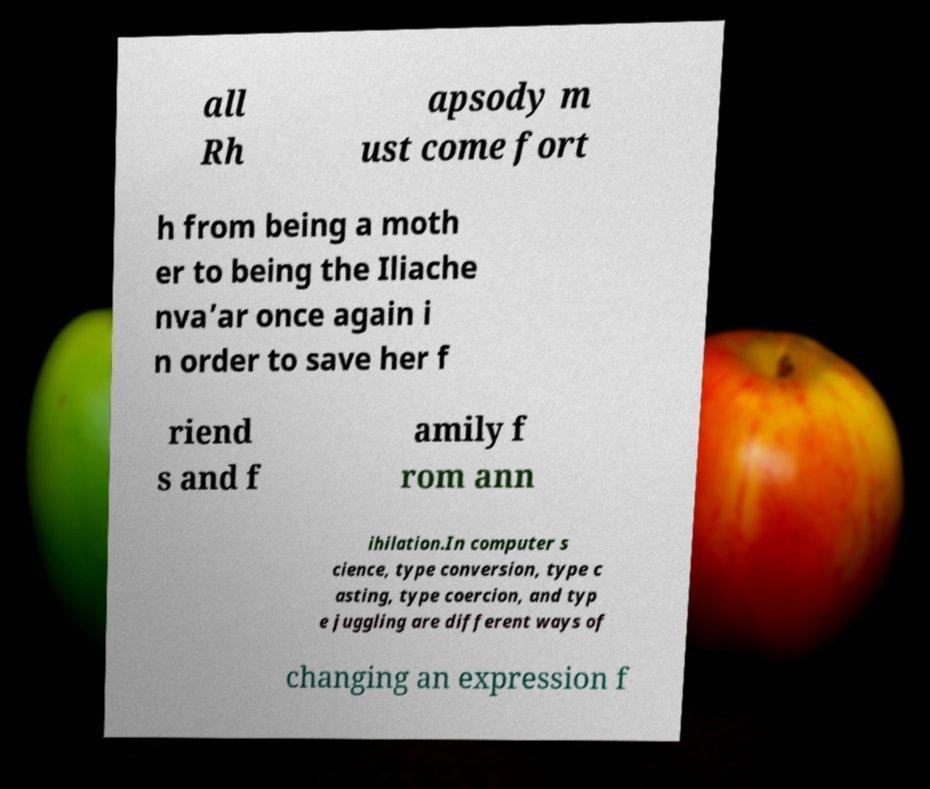Please identify and transcribe the text found in this image. all Rh apsody m ust come fort h from being a moth er to being the Iliache nva’ar once again i n order to save her f riend s and f amily f rom ann ihilation.In computer s cience, type conversion, type c asting, type coercion, and typ e juggling are different ways of changing an expression f 